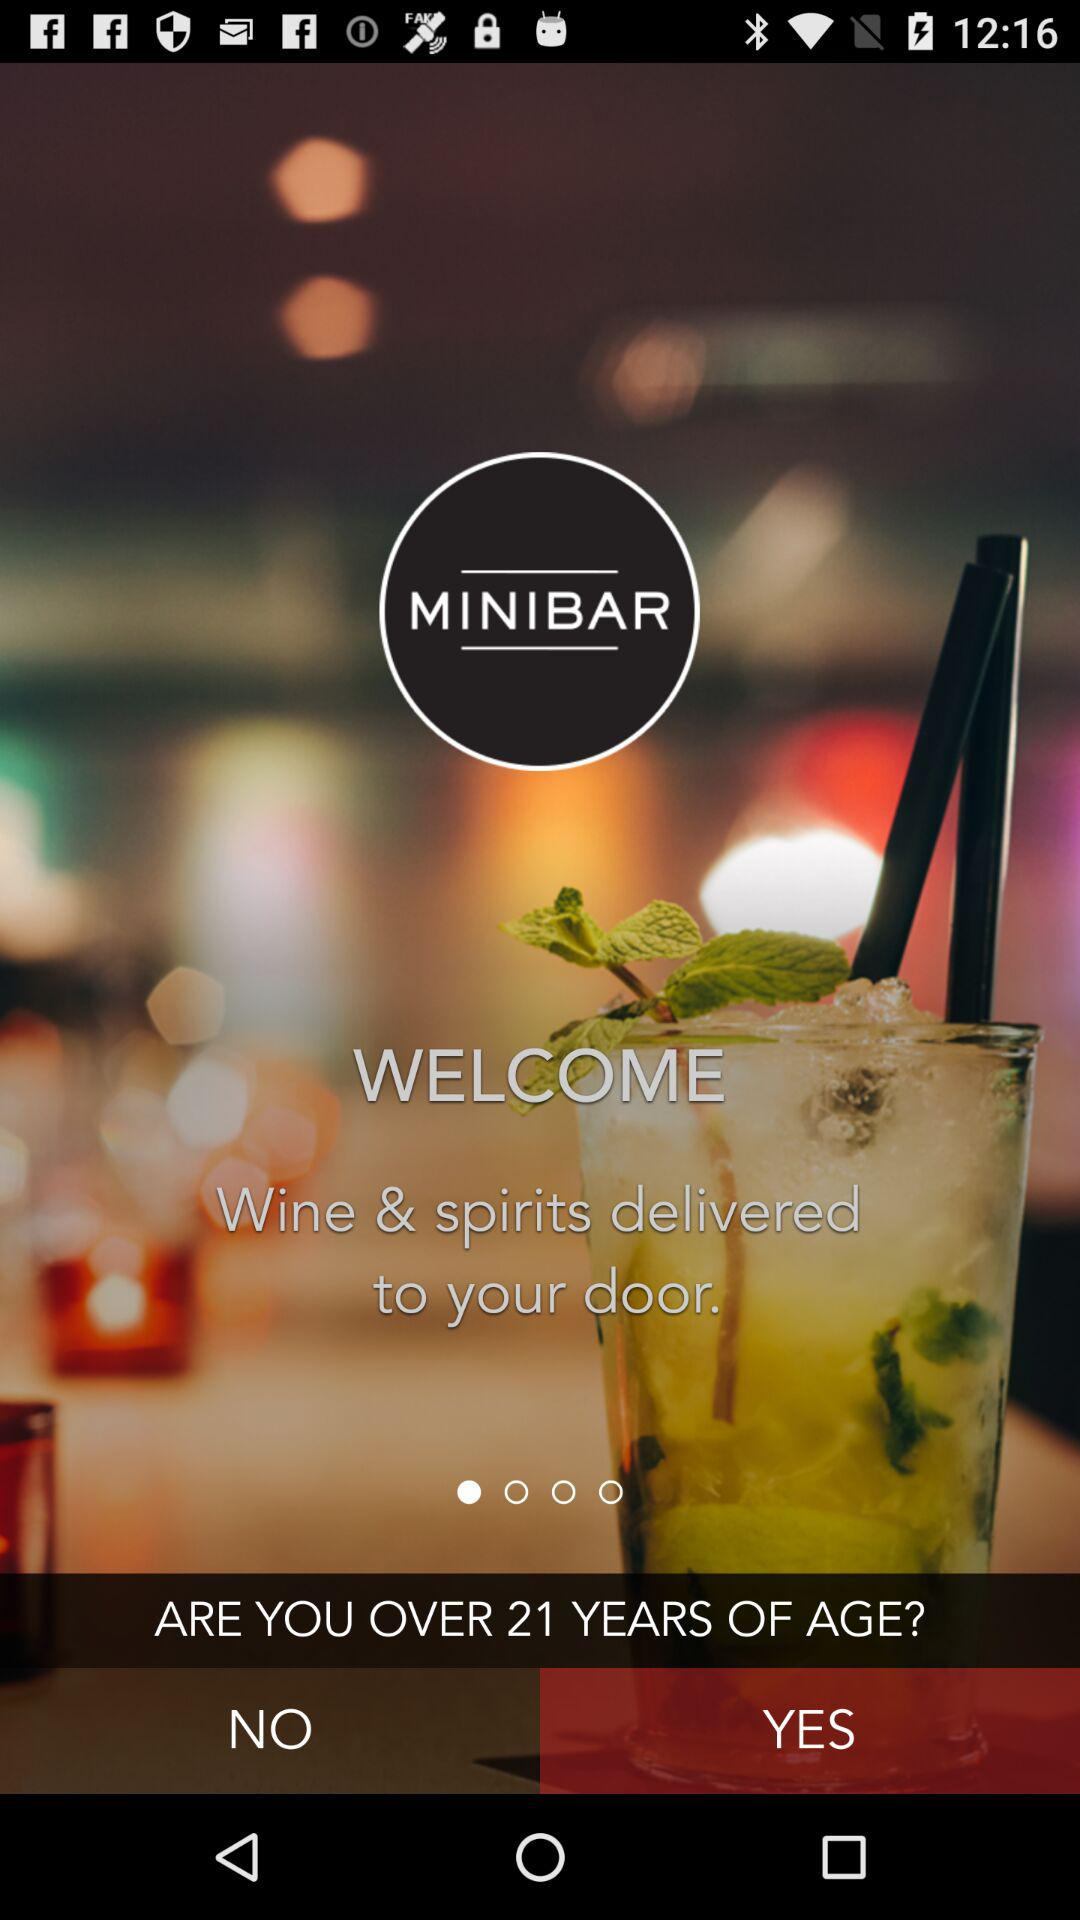What is the name of the application? The name of the application is "MINIBAR". 